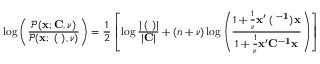<formula> <loc_0><loc_0><loc_500><loc_500>\log \left ( \frac { \mathcal { P } ( { x } ; { C } , \nu ) } { \mathcal { P } ( { x } ; { \Xi } ( { \Lambda } ) , \nu ) } \right ) = \frac { 1 } { 2 } \left [ \log \frac { | { \Xi } ( { \Lambda } ) | } { | { C } | } + ( n + \nu ) \log \left ( \frac { 1 + \frac { 1 } { \nu } x ^ { \prime } { \Xi } ( { \Lambda } ^ { - 1 } ) x } { 1 + \frac { 1 } { \nu } x ^ { \prime } C ^ { - 1 } x } \right ) \right ]</formula> 